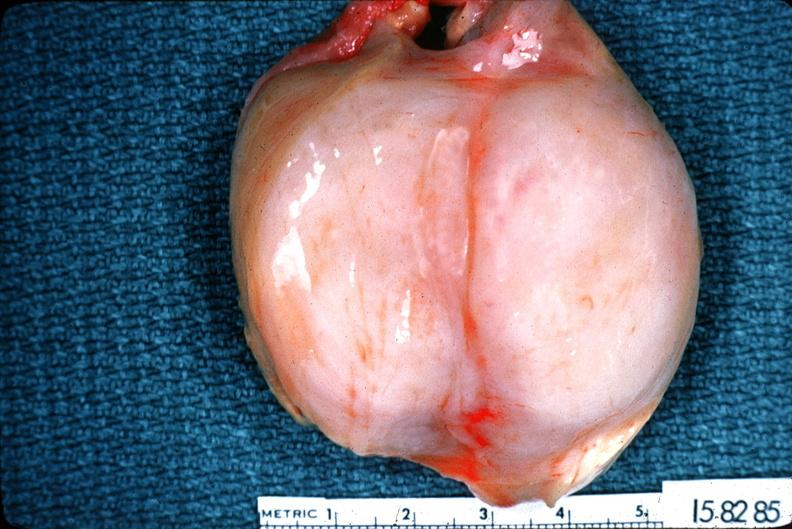s nervous present?
Answer the question using a single word or phrase. Yes 